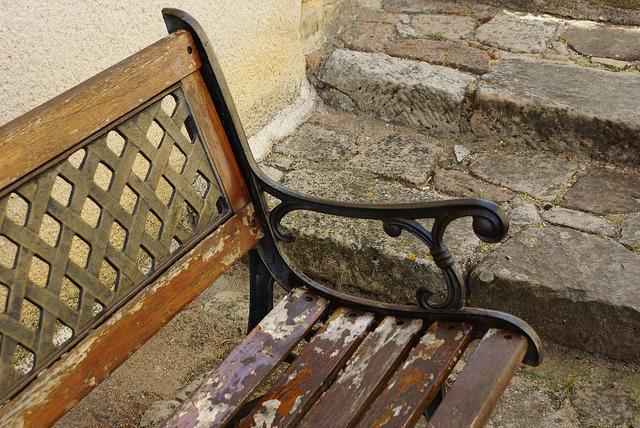How many steps are visible?
Give a very brief answer. 2. How many horses in this photo?
Give a very brief answer. 0. 